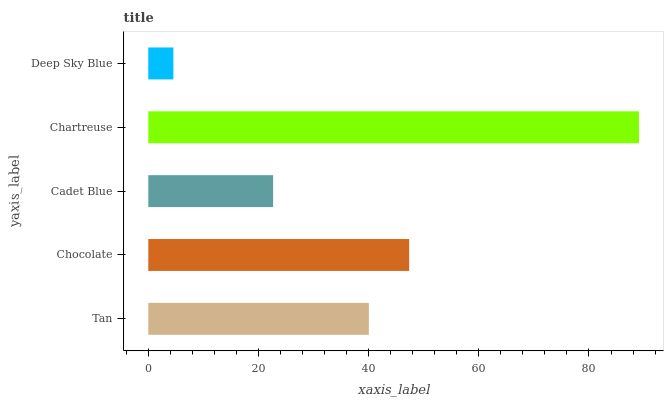Is Deep Sky Blue the minimum?
Answer yes or no. Yes. Is Chartreuse the maximum?
Answer yes or no. Yes. Is Chocolate the minimum?
Answer yes or no. No. Is Chocolate the maximum?
Answer yes or no. No. Is Chocolate greater than Tan?
Answer yes or no. Yes. Is Tan less than Chocolate?
Answer yes or no. Yes. Is Tan greater than Chocolate?
Answer yes or no. No. Is Chocolate less than Tan?
Answer yes or no. No. Is Tan the high median?
Answer yes or no. Yes. Is Tan the low median?
Answer yes or no. Yes. Is Chocolate the high median?
Answer yes or no. No. Is Deep Sky Blue the low median?
Answer yes or no. No. 